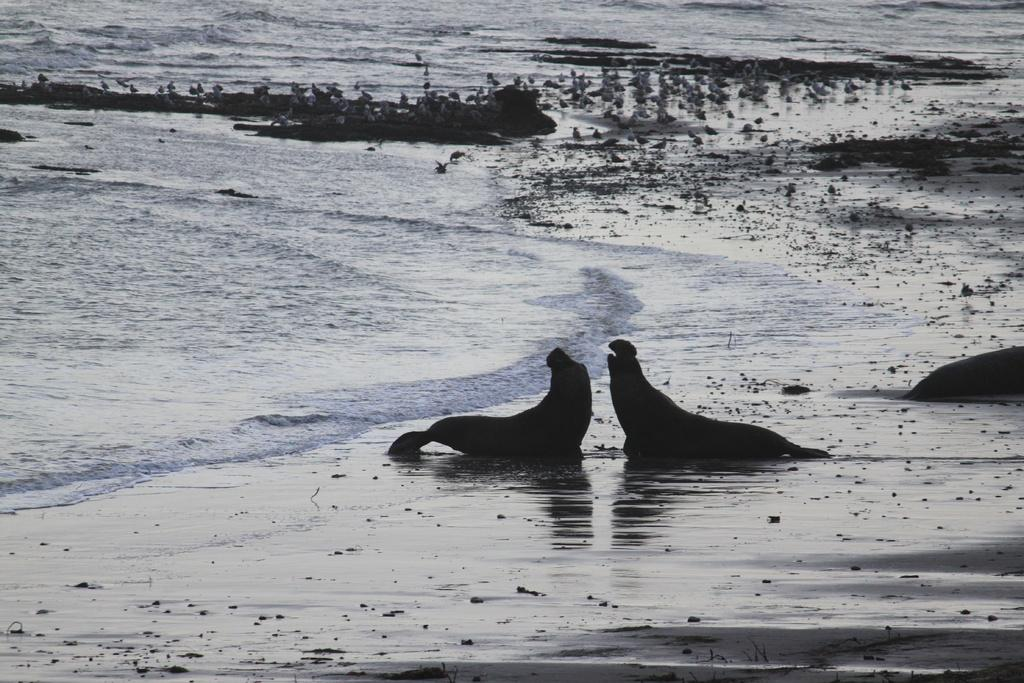What type of animals can be seen in the image? There are animals in the image. What surface are the animals on? The animals are on sand. What can be seen in the background of the image? There is water visible in the background of the image. What type of yam is being argued over by the animals in the image? There is no yam present in the image, nor is there any indication of an argument among the animals. 